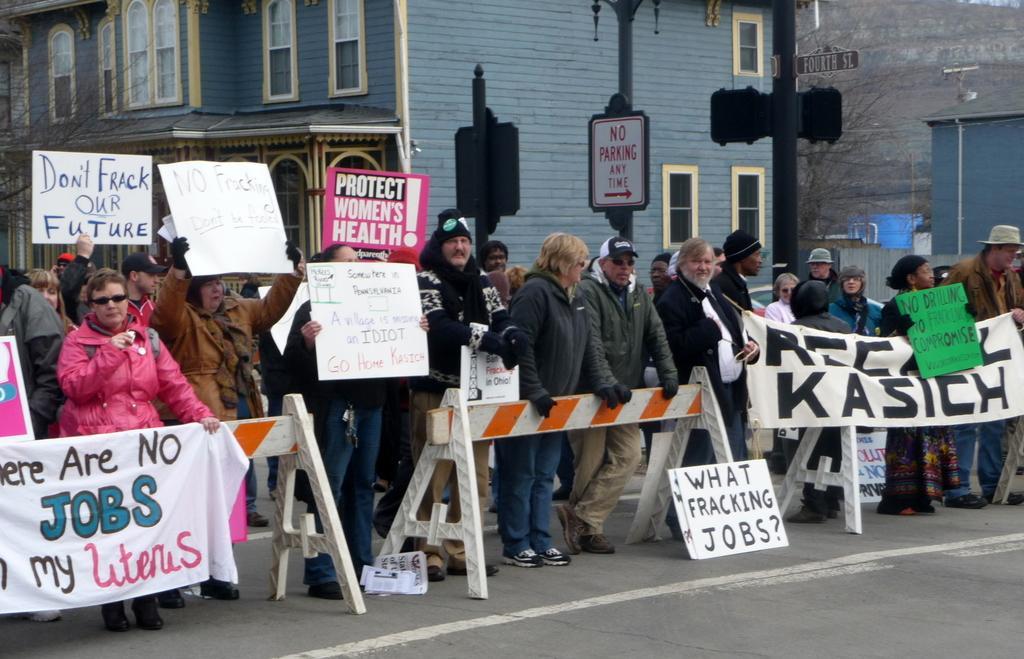In one or two sentences, can you explain what this image depicts? In this image we can see a group of people standing on the road beside some wooden stands. In that some are holding the banners and boards with some text on it. On the backside we can see a building with windows, some poles, a signboard with some text on it and some trees. 